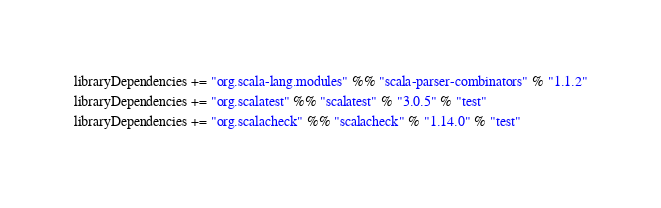<code> <loc_0><loc_0><loc_500><loc_500><_Scala_>libraryDependencies += "org.scala-lang.modules" %% "scala-parser-combinators" % "1.1.2"
libraryDependencies += "org.scalatest" %% "scalatest" % "3.0.5" % "test"
libraryDependencies += "org.scalacheck" %% "scalacheck" % "1.14.0" % "test"
</code> 